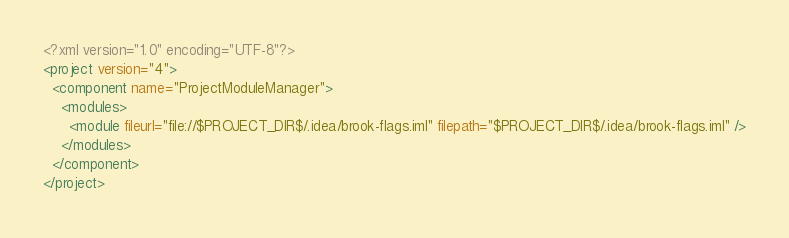<code> <loc_0><loc_0><loc_500><loc_500><_XML_><?xml version="1.0" encoding="UTF-8"?>
<project version="4">
  <component name="ProjectModuleManager">
    <modules>
      <module fileurl="file://$PROJECT_DIR$/.idea/brook-flags.iml" filepath="$PROJECT_DIR$/.idea/brook-flags.iml" />
    </modules>
  </component>
</project></code> 